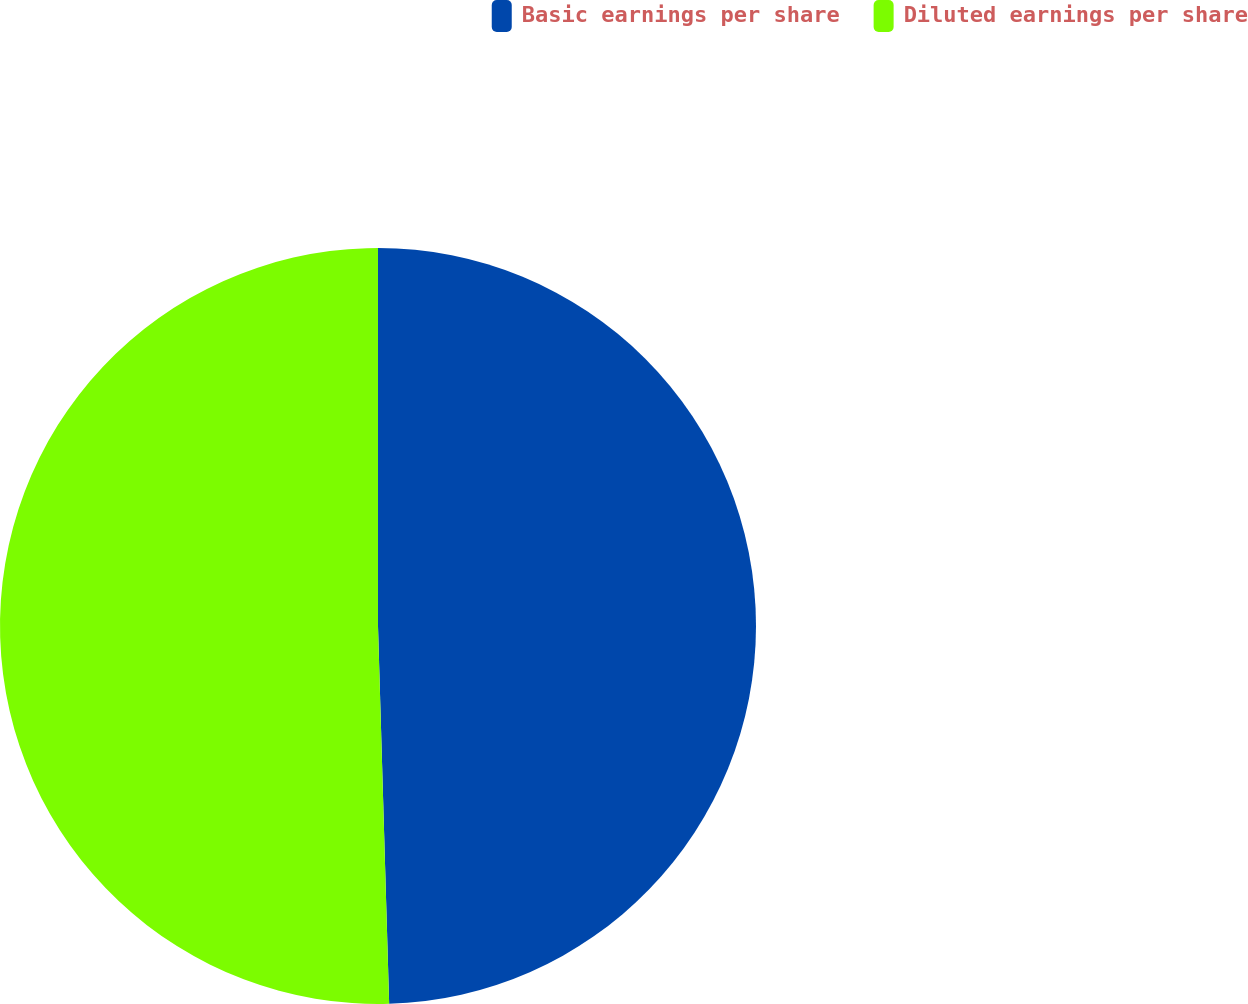Convert chart. <chart><loc_0><loc_0><loc_500><loc_500><pie_chart><fcel>Basic earnings per share<fcel>Diluted earnings per share<nl><fcel>49.53%<fcel>50.47%<nl></chart> 